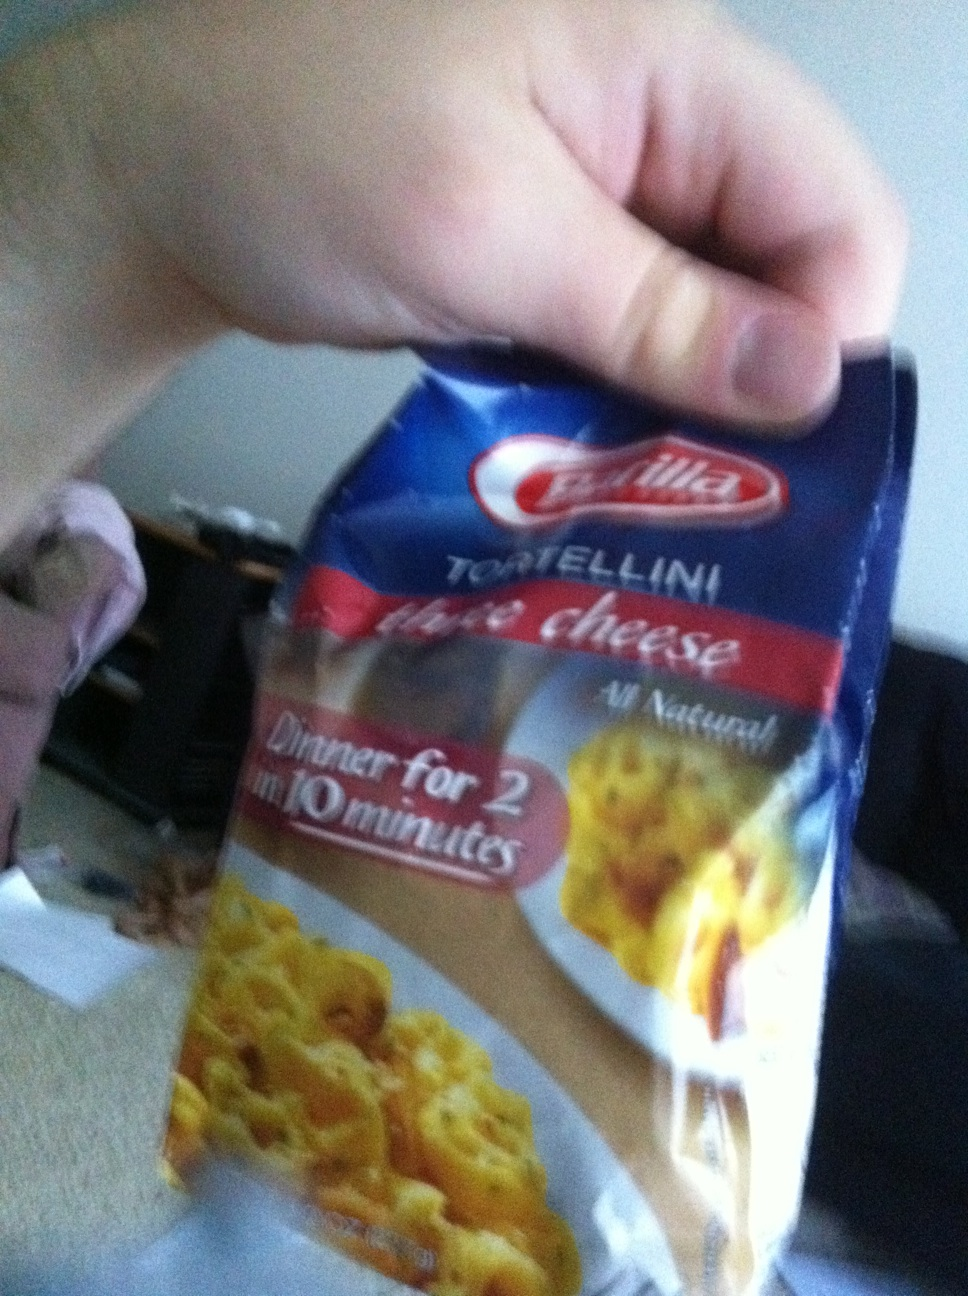Imagine you are hosting an elaborate Italian-themed dinner party. How would you incorporate this tortellini into the meal? For an Italian-themed dinner party, the Barilla three cheese tortellini can be incorporated as a delightful primo piatto (first course). You could serve it in a delicate sauce of sage and brown butter, garnished with fresh parsley and shavings of Parmigiano Reggiano. To enhance the experience, pair it with a light Italian red wine such as Chianti Classico. Complement the tortellini with additional courses including a caprese salad to start, followed by a main course of Osso Buco with risotto, and finish with a classic Tiramisu for dessert. This will provide a well-rounded and authentic Italian dining experience for your guests. 